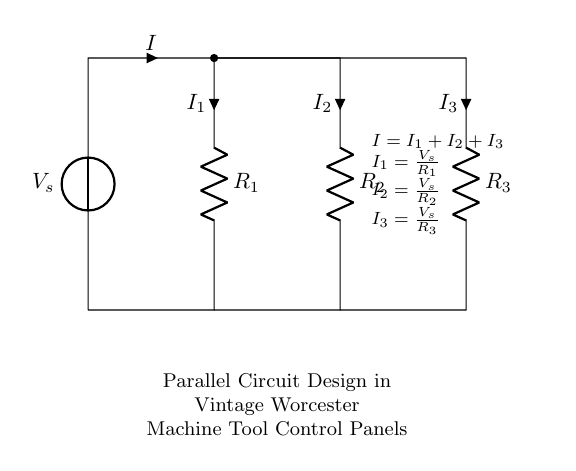What is the source voltage in this circuit? The source voltage, denoted by V_s, is the voltage provided to the circuit from the voltage source. In a typical application, this could be referred to by its label in the diagram.
Answer: V_s How many resistors are present in the circuit? The circuit diagram displays three resistors (R_1, R_2, and R_3) connected in parallel. Counting the distinct labeled components gives the total number.
Answer: 3 What is the total current in the circuit? The total current I is represented in the diagram as the sum of the individual currents I_1, I_2, and I_3 flowing through each resistor. This relationship is clearly stated in the notes within the diagram.
Answer: I = I_1 + I_2 + I_3 What is the individual current through resistor R_2? The current I_2 through resistor R_2 is calculated using Ohm's law, showing that it is equal to the source voltage divided by the resistance of R_2. This is represented in the diagram notes.
Answer: I_2 = V_s / R_2 If R_1 is 10 ohms and V_s is 20 volts, what is I_1? To determine I_1, apply Ohm's law which states current is equal to voltage divided by resistance. Plugging in 20 volts for V_s and 10 ohms for R_1 results in the calculation: I_1 = V_s / R_1 = 20 / 10. Therefore, you can find the value of I_1 directly.
Answer: 2 A What happens to the current when R_3 is removed from the circuit? Removing R_3 would result in the total current being redistributed between R_1 and R_2. Since R_2 remains in circuit, the total current changes according to its resistance, leading to a simplified analysis with only two resistors. The current would be I = I_1 + I_2 as there is no longer an I_3 component.
Answer: Current increases through R_1 and R_2 